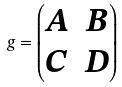Convert formula to latex. <formula><loc_0><loc_0><loc_500><loc_500>g = \begin{pmatrix} A & B \\ C & D \end{pmatrix}</formula> 